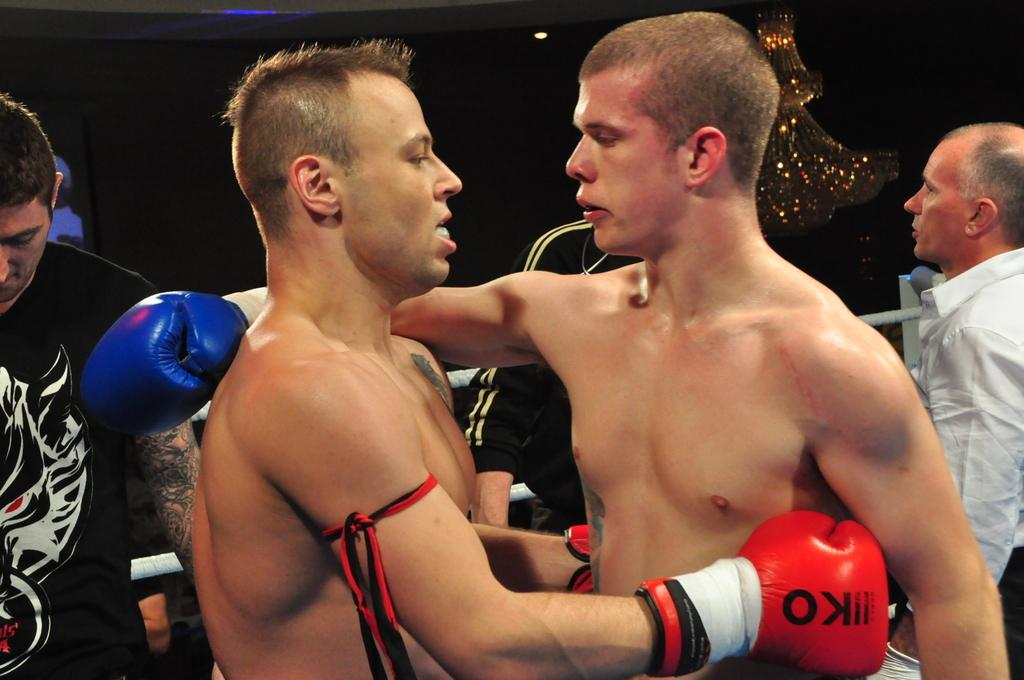<image>
Describe the image concisely. Two boxers are beginning to embrace as one of them wraps his IIKO boxing gloves around the other mans side. 